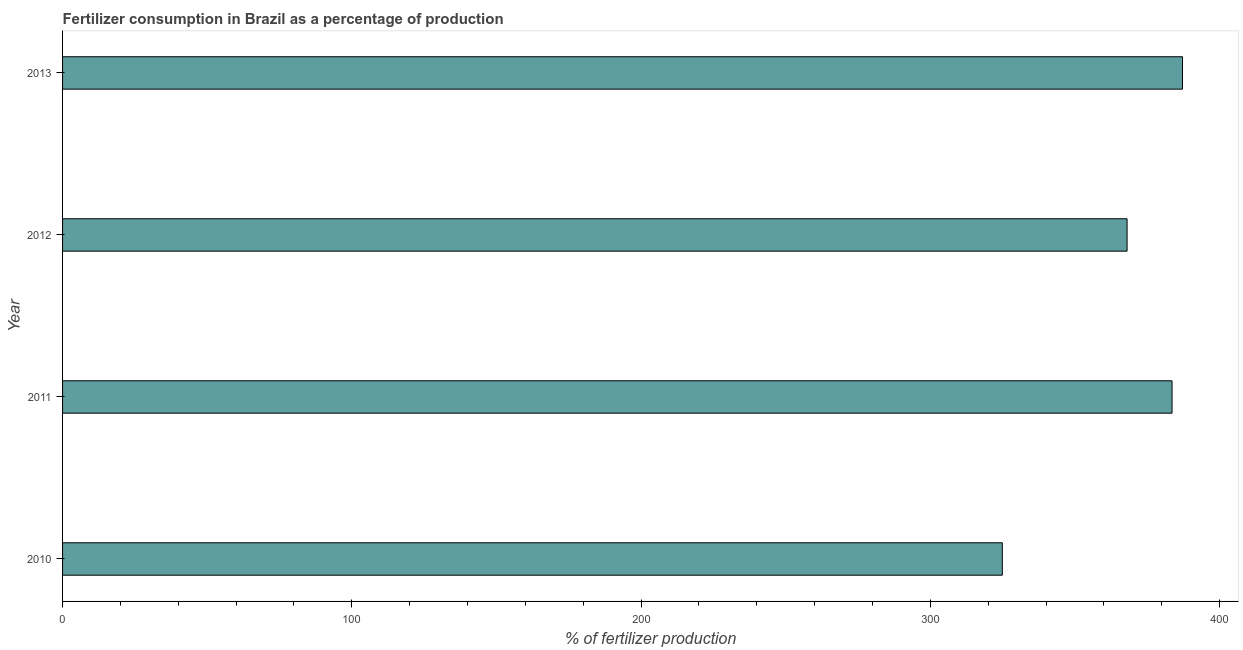What is the title of the graph?
Offer a terse response. Fertilizer consumption in Brazil as a percentage of production. What is the label or title of the X-axis?
Ensure brevity in your answer.  % of fertilizer production. What is the label or title of the Y-axis?
Provide a succinct answer. Year. What is the amount of fertilizer consumption in 2010?
Make the answer very short. 324.87. Across all years, what is the maximum amount of fertilizer consumption?
Offer a very short reply. 387.15. Across all years, what is the minimum amount of fertilizer consumption?
Ensure brevity in your answer.  324.87. In which year was the amount of fertilizer consumption maximum?
Provide a succinct answer. 2013. What is the sum of the amount of fertilizer consumption?
Your answer should be compact. 1463.55. What is the difference between the amount of fertilizer consumption in 2011 and 2013?
Give a very brief answer. -3.61. What is the average amount of fertilizer consumption per year?
Ensure brevity in your answer.  365.89. What is the median amount of fertilizer consumption?
Ensure brevity in your answer.  375.76. In how many years, is the amount of fertilizer consumption greater than 200 %?
Give a very brief answer. 4. What is the ratio of the amount of fertilizer consumption in 2010 to that in 2011?
Your answer should be very brief. 0.85. What is the difference between the highest and the second highest amount of fertilizer consumption?
Provide a succinct answer. 3.61. What is the difference between the highest and the lowest amount of fertilizer consumption?
Make the answer very short. 62.28. Are the values on the major ticks of X-axis written in scientific E-notation?
Ensure brevity in your answer.  No. What is the % of fertilizer production of 2010?
Make the answer very short. 324.87. What is the % of fertilizer production in 2011?
Offer a terse response. 383.54. What is the % of fertilizer production in 2012?
Ensure brevity in your answer.  367.99. What is the % of fertilizer production of 2013?
Your response must be concise. 387.15. What is the difference between the % of fertilizer production in 2010 and 2011?
Ensure brevity in your answer.  -58.67. What is the difference between the % of fertilizer production in 2010 and 2012?
Your answer should be compact. -43.12. What is the difference between the % of fertilizer production in 2010 and 2013?
Your response must be concise. -62.28. What is the difference between the % of fertilizer production in 2011 and 2012?
Offer a terse response. 15.54. What is the difference between the % of fertilizer production in 2011 and 2013?
Ensure brevity in your answer.  -3.61. What is the difference between the % of fertilizer production in 2012 and 2013?
Give a very brief answer. -19.16. What is the ratio of the % of fertilizer production in 2010 to that in 2011?
Your answer should be compact. 0.85. What is the ratio of the % of fertilizer production in 2010 to that in 2012?
Your answer should be very brief. 0.88. What is the ratio of the % of fertilizer production in 2010 to that in 2013?
Make the answer very short. 0.84. What is the ratio of the % of fertilizer production in 2011 to that in 2012?
Offer a terse response. 1.04. What is the ratio of the % of fertilizer production in 2011 to that in 2013?
Provide a short and direct response. 0.99. What is the ratio of the % of fertilizer production in 2012 to that in 2013?
Provide a short and direct response. 0.95. 